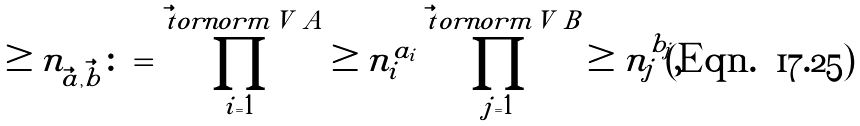Convert formula to latex. <formula><loc_0><loc_0><loc_500><loc_500>\geq n _ { \vec { a } , \vec { b } } \colon = \prod _ { i = 1 } ^ { \vec { t } o r n o r m { V _ { \ } A } } \geq n _ { i } ^ { a _ { i } } \prod _ { j = 1 } ^ { \vec { t } o r n o r m { V _ { \ } B } } \geq n _ { j } ^ { b _ { j } } ,</formula> 